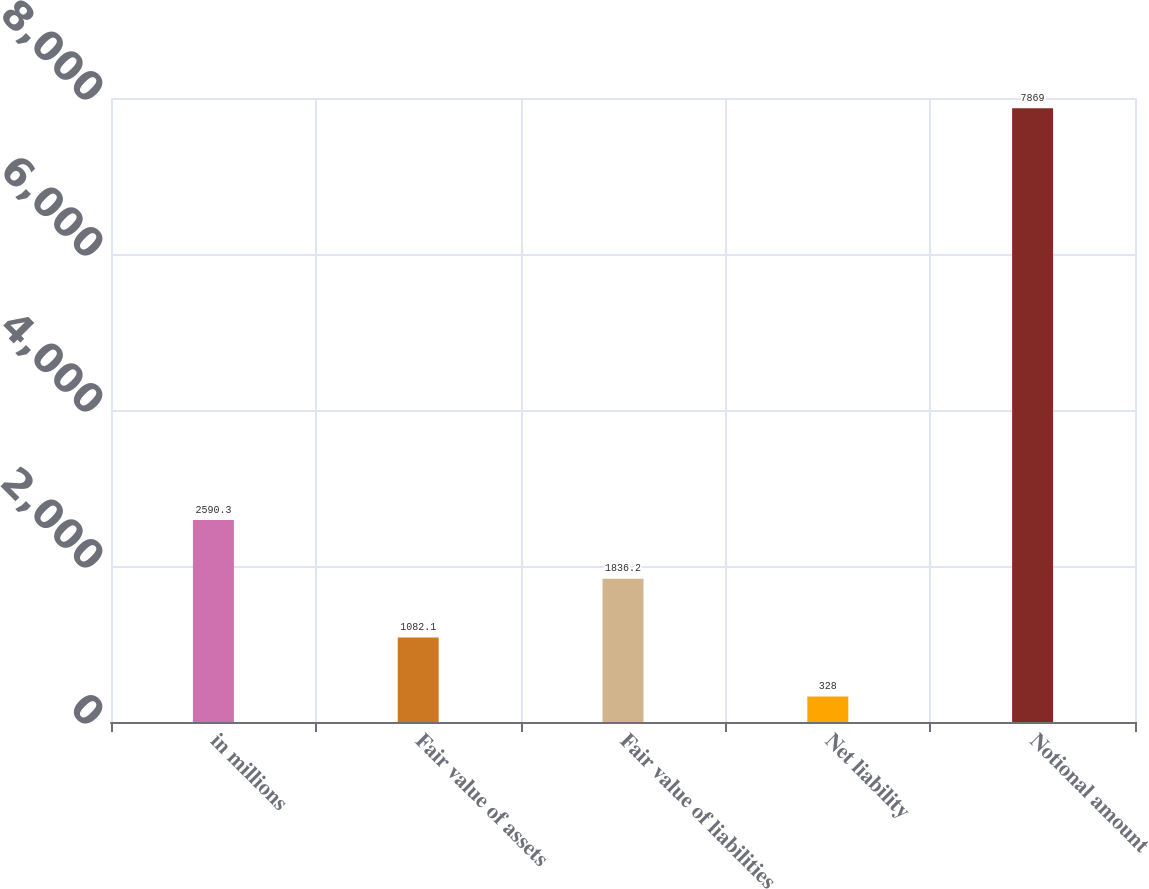<chart> <loc_0><loc_0><loc_500><loc_500><bar_chart><fcel>in millions<fcel>Fair value of assets<fcel>Fair value of liabilities<fcel>Net liability<fcel>Notional amount<nl><fcel>2590.3<fcel>1082.1<fcel>1836.2<fcel>328<fcel>7869<nl></chart> 